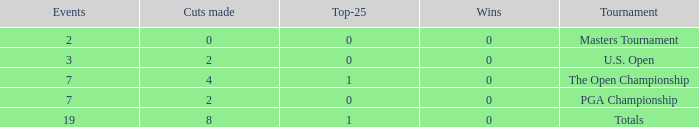What is the lowest Top-25 with Wins less than 0? None. 